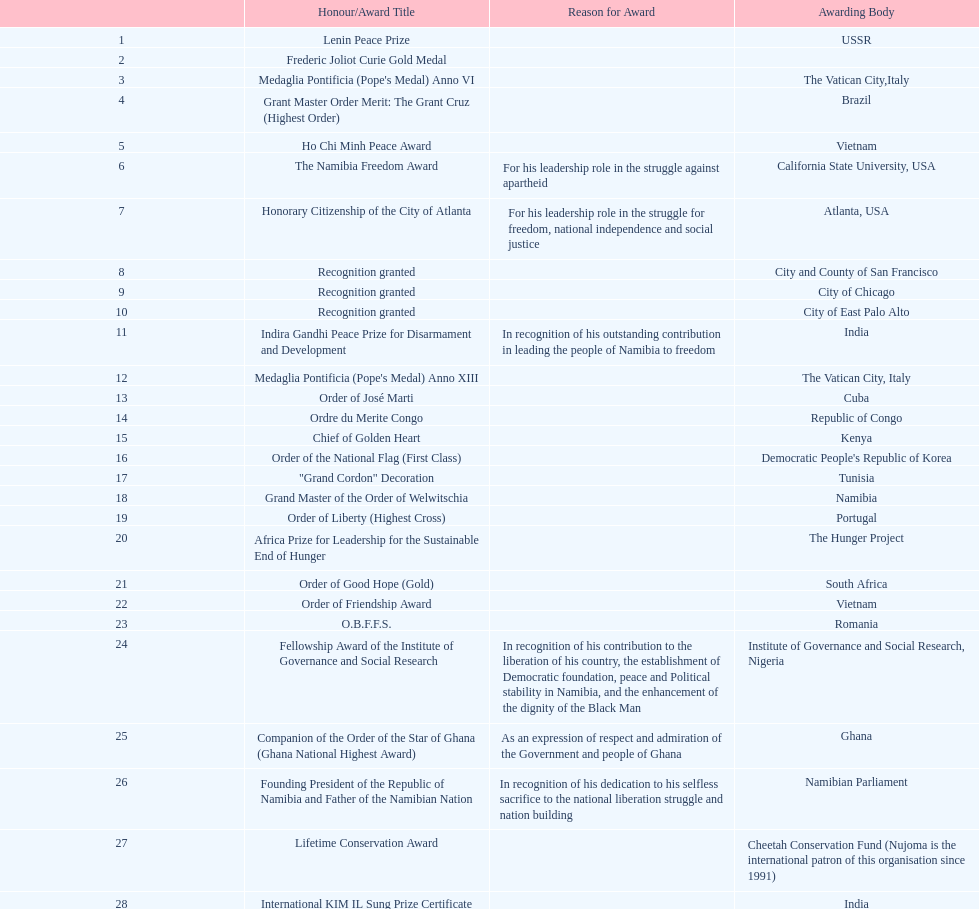What was the last award that nujoma won? Sir Seretse Khama SADC Meda. 